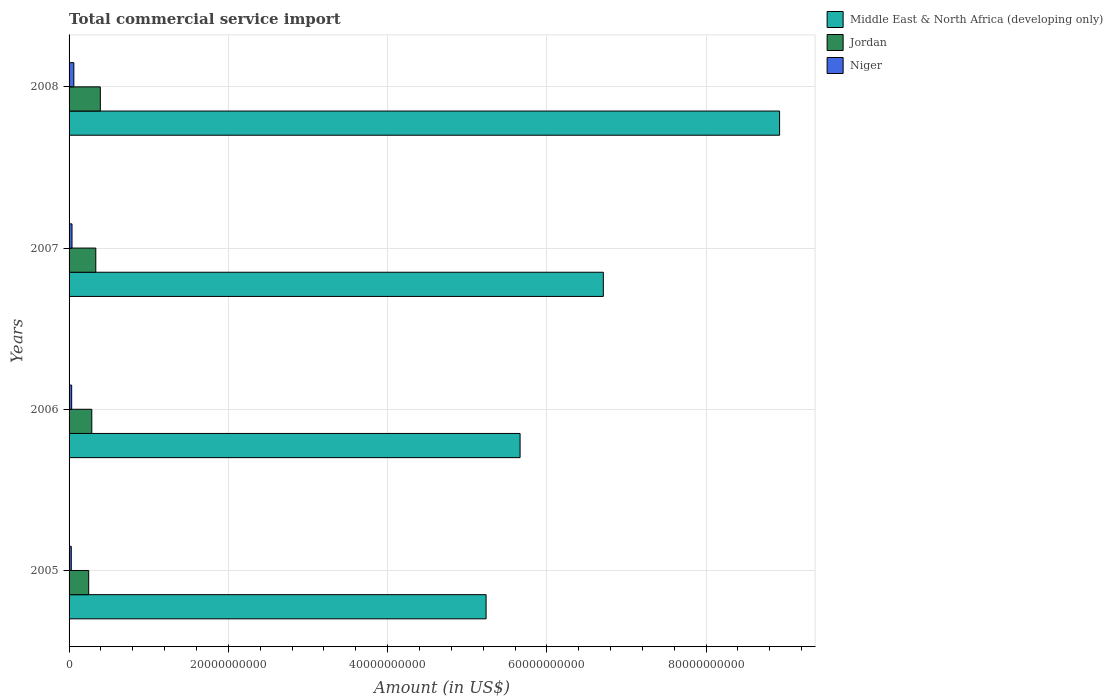Are the number of bars per tick equal to the number of legend labels?
Provide a succinct answer. Yes. How many bars are there on the 3rd tick from the top?
Your answer should be compact. 3. What is the label of the 1st group of bars from the top?
Make the answer very short. 2008. What is the total commercial service import in Niger in 2005?
Your answer should be very brief. 2.78e+08. Across all years, what is the maximum total commercial service import in Jordan?
Make the answer very short. 3.93e+09. Across all years, what is the minimum total commercial service import in Middle East & North Africa (developing only)?
Keep it short and to the point. 5.24e+1. What is the total total commercial service import in Middle East & North Africa (developing only) in the graph?
Keep it short and to the point. 2.65e+11. What is the difference between the total commercial service import in Jordan in 2005 and that in 2006?
Give a very brief answer. -3.89e+08. What is the difference between the total commercial service import in Jordan in 2008 and the total commercial service import in Middle East & North Africa (developing only) in 2007?
Give a very brief answer. -6.32e+1. What is the average total commercial service import in Niger per year?
Your answer should be very brief. 3.94e+08. In the year 2008, what is the difference between the total commercial service import in Middle East & North Africa (developing only) and total commercial service import in Niger?
Give a very brief answer. 8.86e+1. What is the ratio of the total commercial service import in Jordan in 2006 to that in 2008?
Your response must be concise. 0.73. Is the total commercial service import in Jordan in 2005 less than that in 2007?
Your answer should be very brief. Yes. What is the difference between the highest and the second highest total commercial service import in Middle East & North Africa (developing only)?
Provide a succinct answer. 2.21e+1. What is the difference between the highest and the lowest total commercial service import in Middle East & North Africa (developing only)?
Make the answer very short. 3.69e+1. What does the 1st bar from the top in 2005 represents?
Your answer should be very brief. Niger. What does the 2nd bar from the bottom in 2007 represents?
Provide a succinct answer. Jordan. Is it the case that in every year, the sum of the total commercial service import in Jordan and total commercial service import in Middle East & North Africa (developing only) is greater than the total commercial service import in Niger?
Your answer should be very brief. Yes. How many years are there in the graph?
Ensure brevity in your answer.  4. What is the difference between two consecutive major ticks on the X-axis?
Your answer should be very brief. 2.00e+1. Are the values on the major ticks of X-axis written in scientific E-notation?
Offer a very short reply. No. Does the graph contain any zero values?
Provide a succinct answer. No. How many legend labels are there?
Keep it short and to the point. 3. What is the title of the graph?
Keep it short and to the point. Total commercial service import. What is the label or title of the Y-axis?
Your answer should be compact. Years. What is the Amount (in US$) of Middle East & North Africa (developing only) in 2005?
Keep it short and to the point. 5.24e+1. What is the Amount (in US$) in Jordan in 2005?
Provide a short and direct response. 2.46e+09. What is the Amount (in US$) in Niger in 2005?
Offer a very short reply. 2.78e+08. What is the Amount (in US$) in Middle East & North Africa (developing only) in 2006?
Provide a succinct answer. 5.66e+1. What is the Amount (in US$) in Jordan in 2006?
Offer a very short reply. 2.85e+09. What is the Amount (in US$) of Niger in 2006?
Offer a terse response. 3.27e+08. What is the Amount (in US$) in Middle East & North Africa (developing only) in 2007?
Give a very brief answer. 6.71e+1. What is the Amount (in US$) of Jordan in 2007?
Your answer should be compact. 3.36e+09. What is the Amount (in US$) of Niger in 2007?
Keep it short and to the point. 3.69e+08. What is the Amount (in US$) in Middle East & North Africa (developing only) in 2008?
Provide a short and direct response. 8.92e+1. What is the Amount (in US$) of Jordan in 2008?
Ensure brevity in your answer.  3.93e+09. What is the Amount (in US$) of Niger in 2008?
Make the answer very short. 6.00e+08. Across all years, what is the maximum Amount (in US$) of Middle East & North Africa (developing only)?
Give a very brief answer. 8.92e+1. Across all years, what is the maximum Amount (in US$) of Jordan?
Offer a terse response. 3.93e+09. Across all years, what is the maximum Amount (in US$) in Niger?
Your answer should be very brief. 6.00e+08. Across all years, what is the minimum Amount (in US$) of Middle East & North Africa (developing only)?
Your answer should be very brief. 5.24e+1. Across all years, what is the minimum Amount (in US$) in Jordan?
Provide a short and direct response. 2.46e+09. Across all years, what is the minimum Amount (in US$) in Niger?
Ensure brevity in your answer.  2.78e+08. What is the total Amount (in US$) of Middle East & North Africa (developing only) in the graph?
Your answer should be compact. 2.65e+11. What is the total Amount (in US$) in Jordan in the graph?
Provide a short and direct response. 1.26e+1. What is the total Amount (in US$) in Niger in the graph?
Offer a terse response. 1.57e+09. What is the difference between the Amount (in US$) in Middle East & North Africa (developing only) in 2005 and that in 2006?
Make the answer very short. -4.27e+09. What is the difference between the Amount (in US$) of Jordan in 2005 and that in 2006?
Give a very brief answer. -3.89e+08. What is the difference between the Amount (in US$) of Niger in 2005 and that in 2006?
Provide a short and direct response. -4.96e+07. What is the difference between the Amount (in US$) of Middle East & North Africa (developing only) in 2005 and that in 2007?
Offer a very short reply. -1.47e+1. What is the difference between the Amount (in US$) of Jordan in 2005 and that in 2007?
Provide a short and direct response. -8.91e+08. What is the difference between the Amount (in US$) of Niger in 2005 and that in 2007?
Keep it short and to the point. -9.16e+07. What is the difference between the Amount (in US$) in Middle East & North Africa (developing only) in 2005 and that in 2008?
Keep it short and to the point. -3.69e+1. What is the difference between the Amount (in US$) in Jordan in 2005 and that in 2008?
Give a very brief answer. -1.46e+09. What is the difference between the Amount (in US$) of Niger in 2005 and that in 2008?
Make the answer very short. -3.22e+08. What is the difference between the Amount (in US$) in Middle East & North Africa (developing only) in 2006 and that in 2007?
Your answer should be very brief. -1.05e+1. What is the difference between the Amount (in US$) in Jordan in 2006 and that in 2007?
Provide a short and direct response. -5.02e+08. What is the difference between the Amount (in US$) of Niger in 2006 and that in 2007?
Ensure brevity in your answer.  -4.21e+07. What is the difference between the Amount (in US$) in Middle East & North Africa (developing only) in 2006 and that in 2008?
Keep it short and to the point. -3.26e+1. What is the difference between the Amount (in US$) in Jordan in 2006 and that in 2008?
Offer a very short reply. -1.07e+09. What is the difference between the Amount (in US$) of Niger in 2006 and that in 2008?
Offer a terse response. -2.73e+08. What is the difference between the Amount (in US$) of Middle East & North Africa (developing only) in 2007 and that in 2008?
Provide a succinct answer. -2.21e+1. What is the difference between the Amount (in US$) in Jordan in 2007 and that in 2008?
Your answer should be compact. -5.70e+08. What is the difference between the Amount (in US$) in Niger in 2007 and that in 2008?
Offer a very short reply. -2.30e+08. What is the difference between the Amount (in US$) in Middle East & North Africa (developing only) in 2005 and the Amount (in US$) in Jordan in 2006?
Offer a very short reply. 4.95e+1. What is the difference between the Amount (in US$) of Middle East & North Africa (developing only) in 2005 and the Amount (in US$) of Niger in 2006?
Ensure brevity in your answer.  5.20e+1. What is the difference between the Amount (in US$) in Jordan in 2005 and the Amount (in US$) in Niger in 2006?
Make the answer very short. 2.14e+09. What is the difference between the Amount (in US$) in Middle East & North Africa (developing only) in 2005 and the Amount (in US$) in Jordan in 2007?
Your answer should be compact. 4.90e+1. What is the difference between the Amount (in US$) in Middle East & North Africa (developing only) in 2005 and the Amount (in US$) in Niger in 2007?
Your answer should be compact. 5.20e+1. What is the difference between the Amount (in US$) of Jordan in 2005 and the Amount (in US$) of Niger in 2007?
Ensure brevity in your answer.  2.10e+09. What is the difference between the Amount (in US$) in Middle East & North Africa (developing only) in 2005 and the Amount (in US$) in Jordan in 2008?
Make the answer very short. 4.84e+1. What is the difference between the Amount (in US$) of Middle East & North Africa (developing only) in 2005 and the Amount (in US$) of Niger in 2008?
Keep it short and to the point. 5.18e+1. What is the difference between the Amount (in US$) of Jordan in 2005 and the Amount (in US$) of Niger in 2008?
Offer a very short reply. 1.87e+09. What is the difference between the Amount (in US$) of Middle East & North Africa (developing only) in 2006 and the Amount (in US$) of Jordan in 2007?
Ensure brevity in your answer.  5.33e+1. What is the difference between the Amount (in US$) of Middle East & North Africa (developing only) in 2006 and the Amount (in US$) of Niger in 2007?
Offer a terse response. 5.63e+1. What is the difference between the Amount (in US$) in Jordan in 2006 and the Amount (in US$) in Niger in 2007?
Your answer should be compact. 2.48e+09. What is the difference between the Amount (in US$) in Middle East & North Africa (developing only) in 2006 and the Amount (in US$) in Jordan in 2008?
Your response must be concise. 5.27e+1. What is the difference between the Amount (in US$) of Middle East & North Africa (developing only) in 2006 and the Amount (in US$) of Niger in 2008?
Give a very brief answer. 5.60e+1. What is the difference between the Amount (in US$) in Jordan in 2006 and the Amount (in US$) in Niger in 2008?
Give a very brief answer. 2.25e+09. What is the difference between the Amount (in US$) of Middle East & North Africa (developing only) in 2007 and the Amount (in US$) of Jordan in 2008?
Provide a succinct answer. 6.32e+1. What is the difference between the Amount (in US$) of Middle East & North Africa (developing only) in 2007 and the Amount (in US$) of Niger in 2008?
Provide a short and direct response. 6.65e+1. What is the difference between the Amount (in US$) of Jordan in 2007 and the Amount (in US$) of Niger in 2008?
Keep it short and to the point. 2.76e+09. What is the average Amount (in US$) of Middle East & North Africa (developing only) per year?
Make the answer very short. 6.63e+1. What is the average Amount (in US$) of Jordan per year?
Ensure brevity in your answer.  3.15e+09. What is the average Amount (in US$) in Niger per year?
Your answer should be compact. 3.94e+08. In the year 2005, what is the difference between the Amount (in US$) of Middle East & North Africa (developing only) and Amount (in US$) of Jordan?
Provide a short and direct response. 4.99e+1. In the year 2005, what is the difference between the Amount (in US$) of Middle East & North Africa (developing only) and Amount (in US$) of Niger?
Ensure brevity in your answer.  5.21e+1. In the year 2005, what is the difference between the Amount (in US$) in Jordan and Amount (in US$) in Niger?
Your answer should be very brief. 2.19e+09. In the year 2006, what is the difference between the Amount (in US$) of Middle East & North Africa (developing only) and Amount (in US$) of Jordan?
Keep it short and to the point. 5.38e+1. In the year 2006, what is the difference between the Amount (in US$) in Middle East & North Africa (developing only) and Amount (in US$) in Niger?
Your response must be concise. 5.63e+1. In the year 2006, what is the difference between the Amount (in US$) in Jordan and Amount (in US$) in Niger?
Offer a terse response. 2.53e+09. In the year 2007, what is the difference between the Amount (in US$) in Middle East & North Africa (developing only) and Amount (in US$) in Jordan?
Offer a terse response. 6.37e+1. In the year 2007, what is the difference between the Amount (in US$) in Middle East & North Africa (developing only) and Amount (in US$) in Niger?
Provide a short and direct response. 6.67e+1. In the year 2007, what is the difference between the Amount (in US$) in Jordan and Amount (in US$) in Niger?
Offer a very short reply. 2.99e+09. In the year 2008, what is the difference between the Amount (in US$) in Middle East & North Africa (developing only) and Amount (in US$) in Jordan?
Your answer should be very brief. 8.53e+1. In the year 2008, what is the difference between the Amount (in US$) of Middle East & North Africa (developing only) and Amount (in US$) of Niger?
Your answer should be compact. 8.86e+1. In the year 2008, what is the difference between the Amount (in US$) of Jordan and Amount (in US$) of Niger?
Offer a very short reply. 3.33e+09. What is the ratio of the Amount (in US$) of Middle East & North Africa (developing only) in 2005 to that in 2006?
Your answer should be very brief. 0.92. What is the ratio of the Amount (in US$) in Jordan in 2005 to that in 2006?
Offer a terse response. 0.86. What is the ratio of the Amount (in US$) in Niger in 2005 to that in 2006?
Your answer should be very brief. 0.85. What is the ratio of the Amount (in US$) of Middle East & North Africa (developing only) in 2005 to that in 2007?
Your response must be concise. 0.78. What is the ratio of the Amount (in US$) of Jordan in 2005 to that in 2007?
Keep it short and to the point. 0.73. What is the ratio of the Amount (in US$) in Niger in 2005 to that in 2007?
Offer a terse response. 0.75. What is the ratio of the Amount (in US$) in Middle East & North Africa (developing only) in 2005 to that in 2008?
Provide a succinct answer. 0.59. What is the ratio of the Amount (in US$) of Jordan in 2005 to that in 2008?
Your answer should be very brief. 0.63. What is the ratio of the Amount (in US$) of Niger in 2005 to that in 2008?
Make the answer very short. 0.46. What is the ratio of the Amount (in US$) of Middle East & North Africa (developing only) in 2006 to that in 2007?
Make the answer very short. 0.84. What is the ratio of the Amount (in US$) in Jordan in 2006 to that in 2007?
Your answer should be very brief. 0.85. What is the ratio of the Amount (in US$) of Niger in 2006 to that in 2007?
Your response must be concise. 0.89. What is the ratio of the Amount (in US$) of Middle East & North Africa (developing only) in 2006 to that in 2008?
Your response must be concise. 0.63. What is the ratio of the Amount (in US$) of Jordan in 2006 to that in 2008?
Offer a very short reply. 0.73. What is the ratio of the Amount (in US$) of Niger in 2006 to that in 2008?
Ensure brevity in your answer.  0.55. What is the ratio of the Amount (in US$) of Middle East & North Africa (developing only) in 2007 to that in 2008?
Provide a succinct answer. 0.75. What is the ratio of the Amount (in US$) of Jordan in 2007 to that in 2008?
Your answer should be compact. 0.85. What is the ratio of the Amount (in US$) in Niger in 2007 to that in 2008?
Your answer should be very brief. 0.62. What is the difference between the highest and the second highest Amount (in US$) in Middle East & North Africa (developing only)?
Offer a terse response. 2.21e+1. What is the difference between the highest and the second highest Amount (in US$) in Jordan?
Provide a succinct answer. 5.70e+08. What is the difference between the highest and the second highest Amount (in US$) of Niger?
Provide a short and direct response. 2.30e+08. What is the difference between the highest and the lowest Amount (in US$) of Middle East & North Africa (developing only)?
Make the answer very short. 3.69e+1. What is the difference between the highest and the lowest Amount (in US$) of Jordan?
Give a very brief answer. 1.46e+09. What is the difference between the highest and the lowest Amount (in US$) of Niger?
Offer a very short reply. 3.22e+08. 